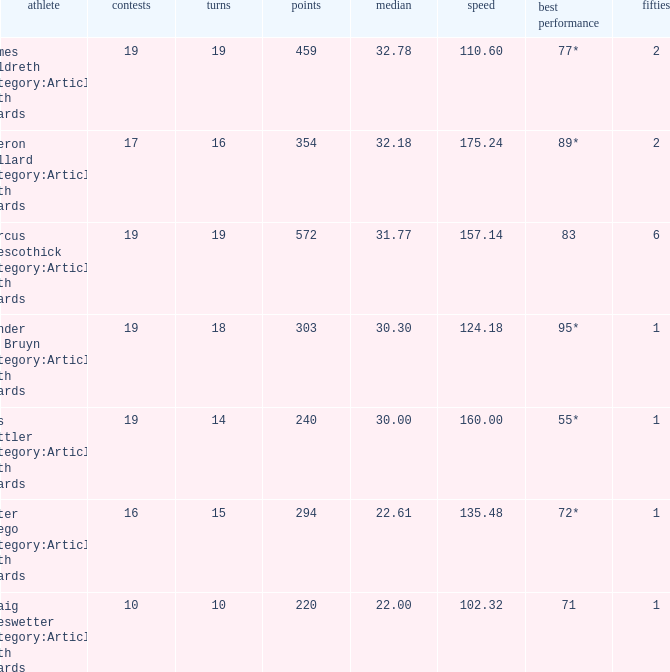What is the highest score for the player with average of 30.00? 55*. 